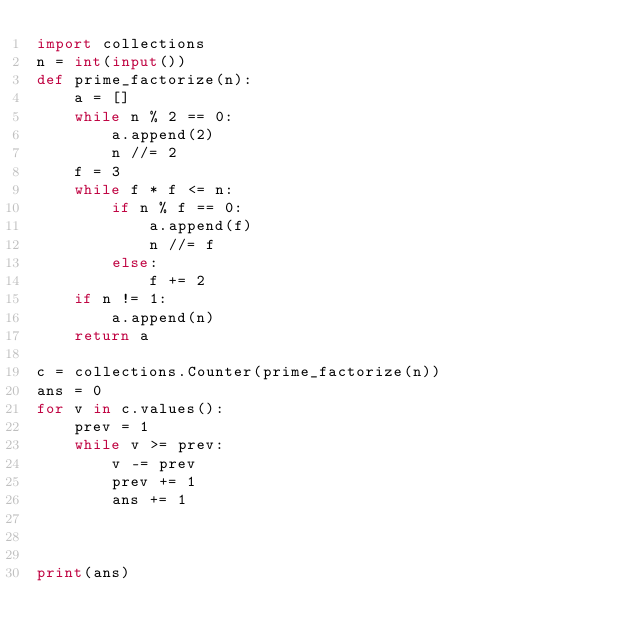<code> <loc_0><loc_0><loc_500><loc_500><_Python_>import collections
n = int(input())
def prime_factorize(n):
    a = []
    while n % 2 == 0:
        a.append(2)
        n //= 2
    f = 3
    while f * f <= n:
        if n % f == 0:
            a.append(f)
            n //= f
        else:
            f += 2
    if n != 1:
        a.append(n)
    return a

c = collections.Counter(prime_factorize(n))
ans = 0
for v in c.values():
    prev = 1
    while v >= prev:
        v -= prev
        prev += 1
        ans += 1
    
    
    
print(ans)</code> 